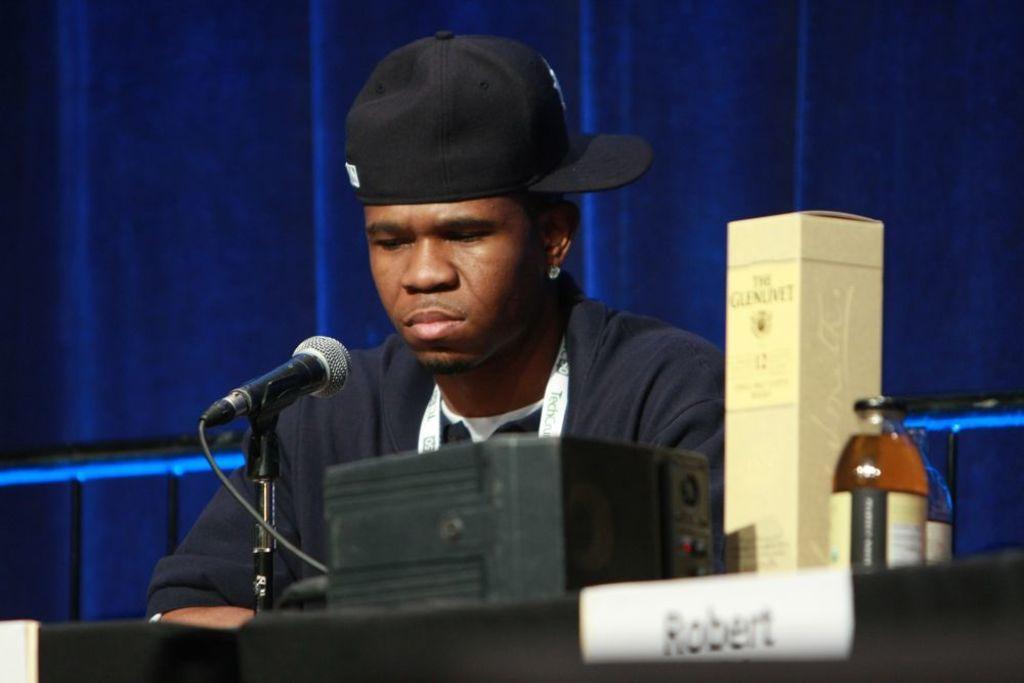Describe this image in one or two sentences. In this picture we can see a man is wearing a black cap, in front of him we can find a microphone, bottles, name board and some other objects on the table, in the background we can see a metal rod. 